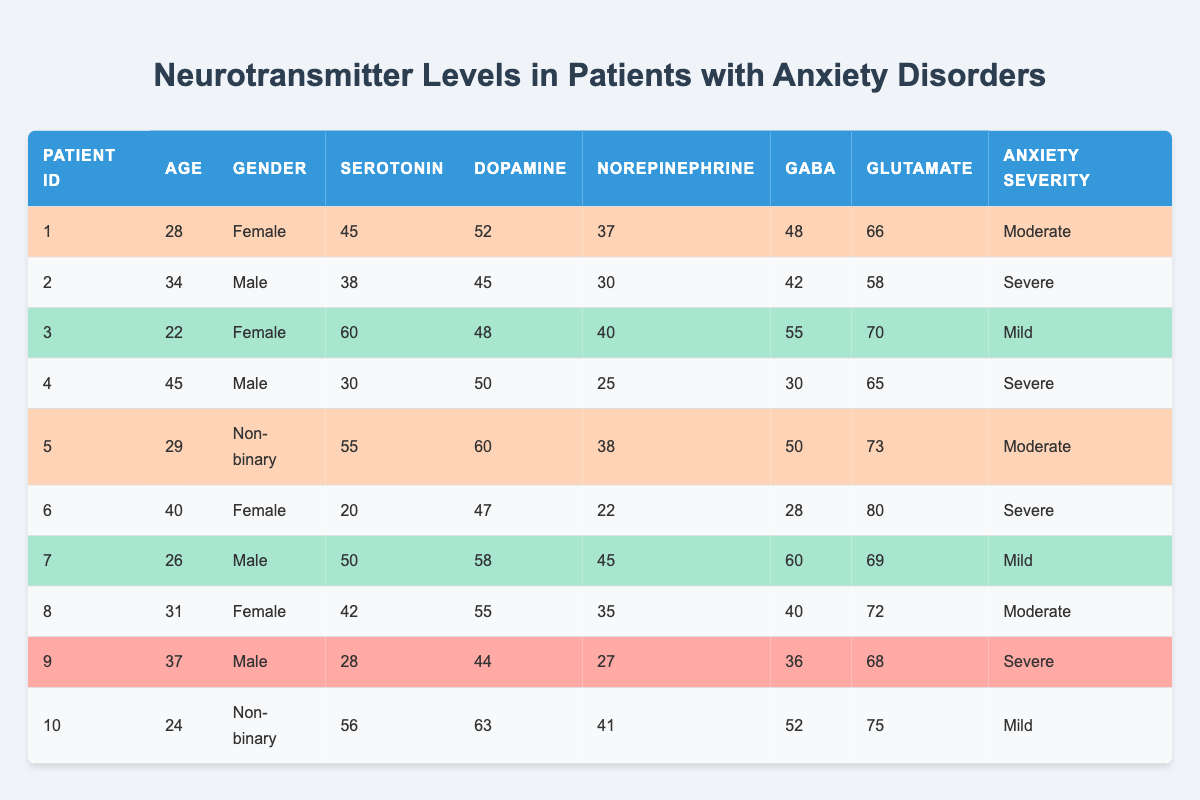What is the serotonin level of patient 5? Patient 5 is in the row corresponding to their data in the table. The serotonin level listed there is 55.
Answer: 55 What is the highest GABA level recorded in the table? By looking through the GABA values in each patient's row, the highest value is found for patient 6, which is 80.
Answer: 80 How many patients have severe anxiety severity? Counting the rows labeled as "Severe," there are four patients (patients 2, 4, 6, and 9).
Answer: 4 What is the average dopamine level for patients with mild anxiety severity? There are three patients with mild anxiety (patients 3, 7, and 10). Their dopamine levels are 48, 58, and 63. The sum is 48 + 58 + 63 = 169. Dividing by 3 gives us an average of 169 / 3 = 56.33.
Answer: 56.33 Is there a patient with all neurotransmitter levels above 60? Checking each patient's levels, patient 6 is confirmed to have some values above 60, but no patient has all values above 60; thus the answer is no.
Answer: No What is the difference between the highest and lowest levels of norepinephrine in the table? The highest norepinephrine level is 45 (patient 7) and the lowest is 22 (patient 6). To find the difference: 45 - 22 = 23.
Answer: 23 Which gender has the highest average serotonin level and what is that average? Summing the serotonin levels by gender: females (55 + 60 + 45 + 42 = 202) and non-binary (56 + 55 = 56). For males: (38 + 30 + 28 = 96). The average for females is 202 / 4 = 50.5, for non-binary is (55 + 56) / 2 = 55.5, and for males is 96 / 3 = 32. This shows females have the highest average serotonin level.
Answer: Female, 50.5 What percentage of patients have moderate anxiety severity? There are 10 patients total, with 3 having moderate anxiety severity (patients 1, 5, and 8). To calculate the percentage: (3/10) * 100 = 30%.
Answer: 30% How does the glutamate level of patient 10 compare to the average glutamate level of all patients? Patient 10's glutamate level is 75; the total glutamate levels are (66 + 58 + 70 + 65 + 73 + 80 + 69 + 72 + 68 + 75) =  69.7 and dividing gives an average of 69.8 of glutamate levels across all patients = 69.8. So, patient 10's level is higher, specifically 75 compared to the average of 69.8.
Answer: Higher than average 